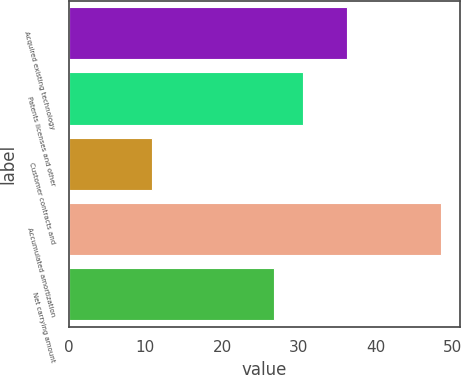<chart> <loc_0><loc_0><loc_500><loc_500><bar_chart><fcel>Acquired existing technology<fcel>Patents licenses and other<fcel>Customer contracts and<fcel>Accumulated amortization<fcel>Net carrying amount<nl><fcel>36.3<fcel>30.56<fcel>10.9<fcel>48.5<fcel>26.8<nl></chart> 